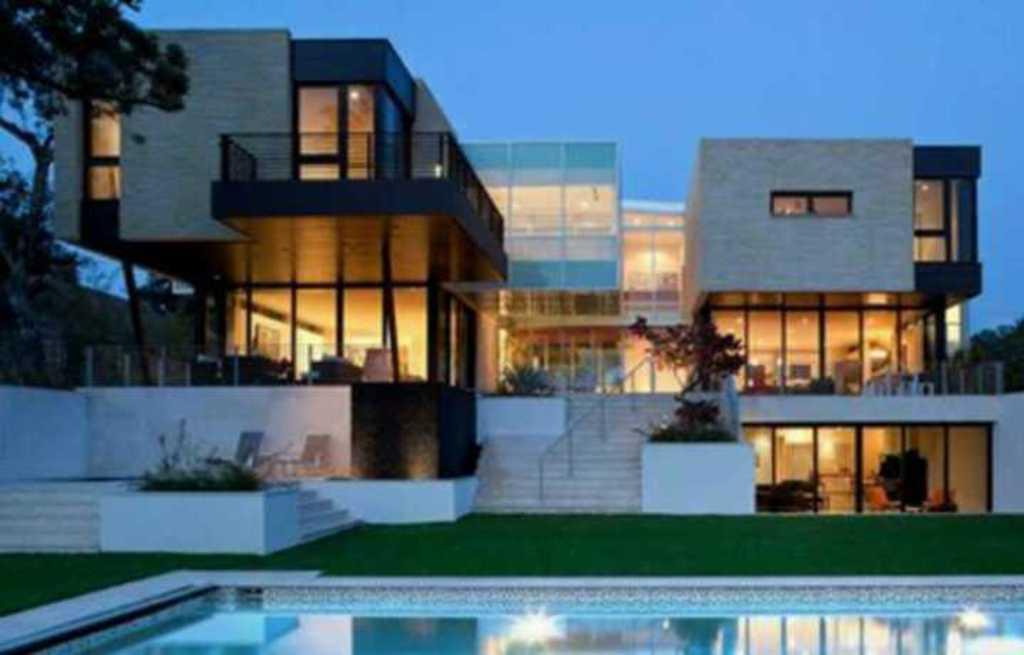What is the main subject of the image? The image shows the front view of a building. What type of vegetation can be seen in the image? There are trees, plants, and grass visible in the image. What recreational feature is present in the image? There is a swimming pool in the image. Are there any architectural elements visible in the image? Yes, there are stairs in the image. What is visible at the top of the image? The sky is visible at the top of the image. What type of soda is being served in the tub in the image? There is no tub or soda present in the image; it features a building with a swimming pool and natural elements. 